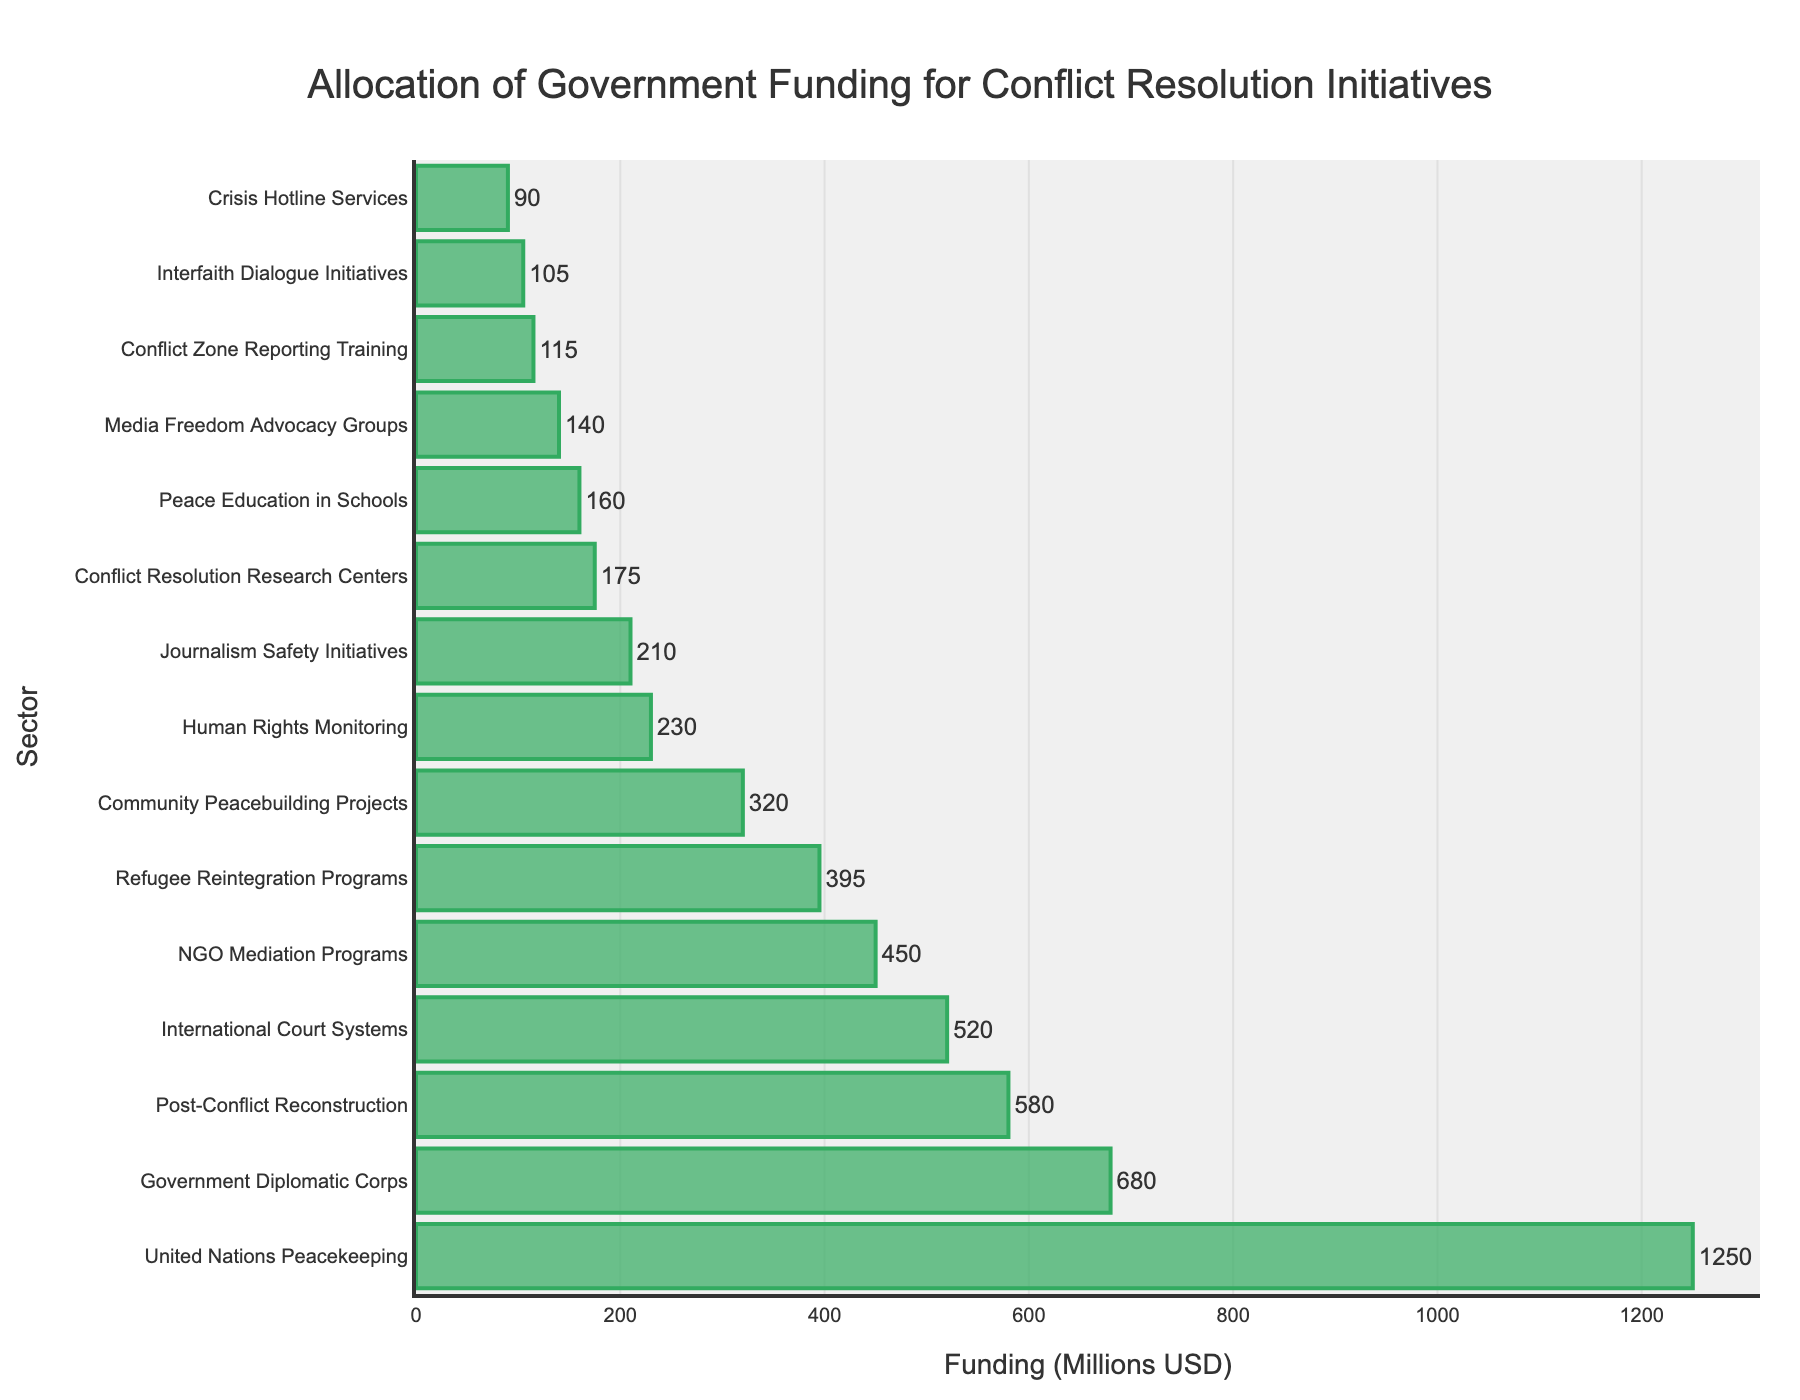Which sector receives the highest funding? Look at the bar with the greatest length. The United Nations Peacekeeping bar is the longest, indicating it receives the highest funding.
Answer: United Nations Peacekeeping What's the total funding allocated to the top three funded sectors? Identify the top three sectors with the highest funding. Sum their funding amounts. United Nations Peacekeeping (1250) + Government Diplomatic Corps (680) + Post-Conflict Reconstruction (580) = 2510.
Answer: 2510 Which sector receives more funding: Refugee Reintegration Programs or Crisis Hotline Services? Compare the lengths of the bars for these two sectors. Refugee Reintegration Programs has a longer bar than Crisis Hotline Services.
Answer: Refugee Reintegration Programs How much more funding does Media Freedom Advocacy Groups receive compared to Conflict Zone Reporting Training? Subtract the funding amount of Conflict Zone Reporting Training from Media Freedom Advocacy Groups. 140 (Media) - 115 (Conflict) = 25.
Answer: 25 What's the combined funding for sectors related to media and journalism (Journalism Safety Initiatives, Media Freedom Advocacy Groups, Conflict Zone Reporting Training)? Sum the funding amounts for these sectors. 210 (Journalism Safety Initiatives) + 140 (Media Freedom Advocacy Groups) + 115 (Conflict Zone Reporting Training) = 465.
Answer: 465 Which sectors receive equal or less than 150 million USD in funding? Identify sectors with bars that correspond to 150 million USD or less. Conflict Resolution Research Centers, Media Freedom Advocacy Groups, Crisis Hotline Services, Conflict Zone Reporting Training, and Interfaith Dialogue Initiatives.
Answer: Conflict Resolution Research Centers, Media Freedom Advocacy Groups, Crisis Hotline Services, Conflict Zone Reporting Training, Interfaith Dialogue Initiatives What is the difference in funding between Government Diplomatic Corps and International Court Systems? Subtract the funding amount of International Court Systems from Government Diplomatic Corps. 680 (Government Diplomatic Corps) - 520 (International Court Systems) = 160.
Answer: 160 Calculate the average funding across all sectors. Sum the funding for all sectors and divide by the number of sectors. Total funding is 6390, and there are 15 sectors. Average = 6390 / 15 ≈ 426.
Answer: 426 